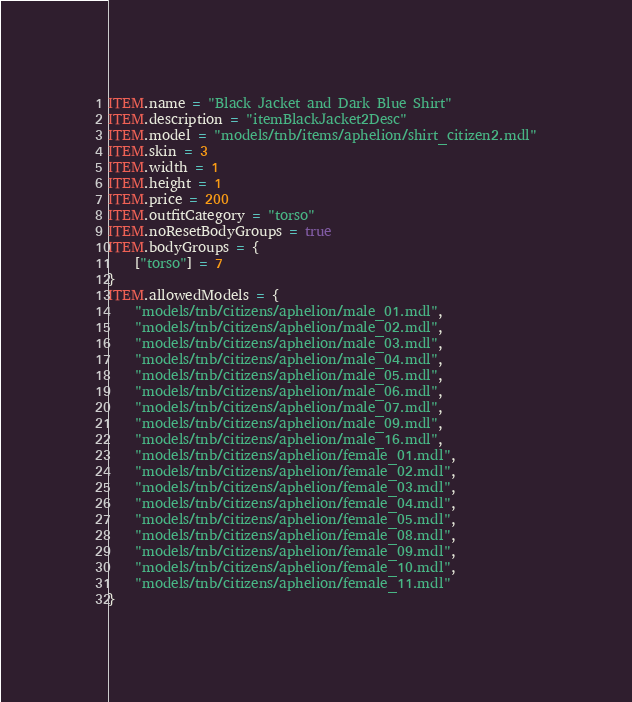Convert code to text. <code><loc_0><loc_0><loc_500><loc_500><_Lua_>ITEM.name = "Black Jacket and Dark Blue Shirt"
ITEM.description = "itemBlackJacket2Desc"
ITEM.model = "models/tnb/items/aphelion/shirt_citizen2.mdl"
ITEM.skin = 3
ITEM.width = 1
ITEM.height = 1
ITEM.price = 200
ITEM.outfitCategory = "torso"
ITEM.noResetBodyGroups = true
ITEM.bodyGroups = {
	["torso"] = 7
}
ITEM.allowedModels = {
	"models/tnb/citizens/aphelion/male_01.mdl",
	"models/tnb/citizens/aphelion/male_02.mdl",
	"models/tnb/citizens/aphelion/male_03.mdl",
	"models/tnb/citizens/aphelion/male_04.mdl",
	"models/tnb/citizens/aphelion/male_05.mdl",
	"models/tnb/citizens/aphelion/male_06.mdl",
	"models/tnb/citizens/aphelion/male_07.mdl",
	"models/tnb/citizens/aphelion/male_09.mdl",
	"models/tnb/citizens/aphelion/male_16.mdl",
	"models/tnb/citizens/aphelion/female_01.mdl",
	"models/tnb/citizens/aphelion/female_02.mdl",
	"models/tnb/citizens/aphelion/female_03.mdl",
	"models/tnb/citizens/aphelion/female_04.mdl",
	"models/tnb/citizens/aphelion/female_05.mdl",
	"models/tnb/citizens/aphelion/female_08.mdl",
	"models/tnb/citizens/aphelion/female_09.mdl",
	"models/tnb/citizens/aphelion/female_10.mdl",
	"models/tnb/citizens/aphelion/female_11.mdl"
}</code> 